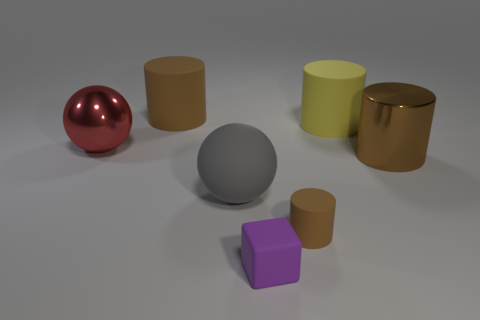How many brown cylinders must be subtracted to get 1 brown cylinders? 2 Subtract all brown spheres. How many brown cylinders are left? 3 Subtract 1 cylinders. How many cylinders are left? 3 Add 1 red spheres. How many objects exist? 8 Subtract all balls. How many objects are left? 5 Subtract 1 yellow cylinders. How many objects are left? 6 Subtract all big red metallic balls. Subtract all large spheres. How many objects are left? 4 Add 7 big brown things. How many big brown things are left? 9 Add 4 red matte cylinders. How many red matte cylinders exist? 4 